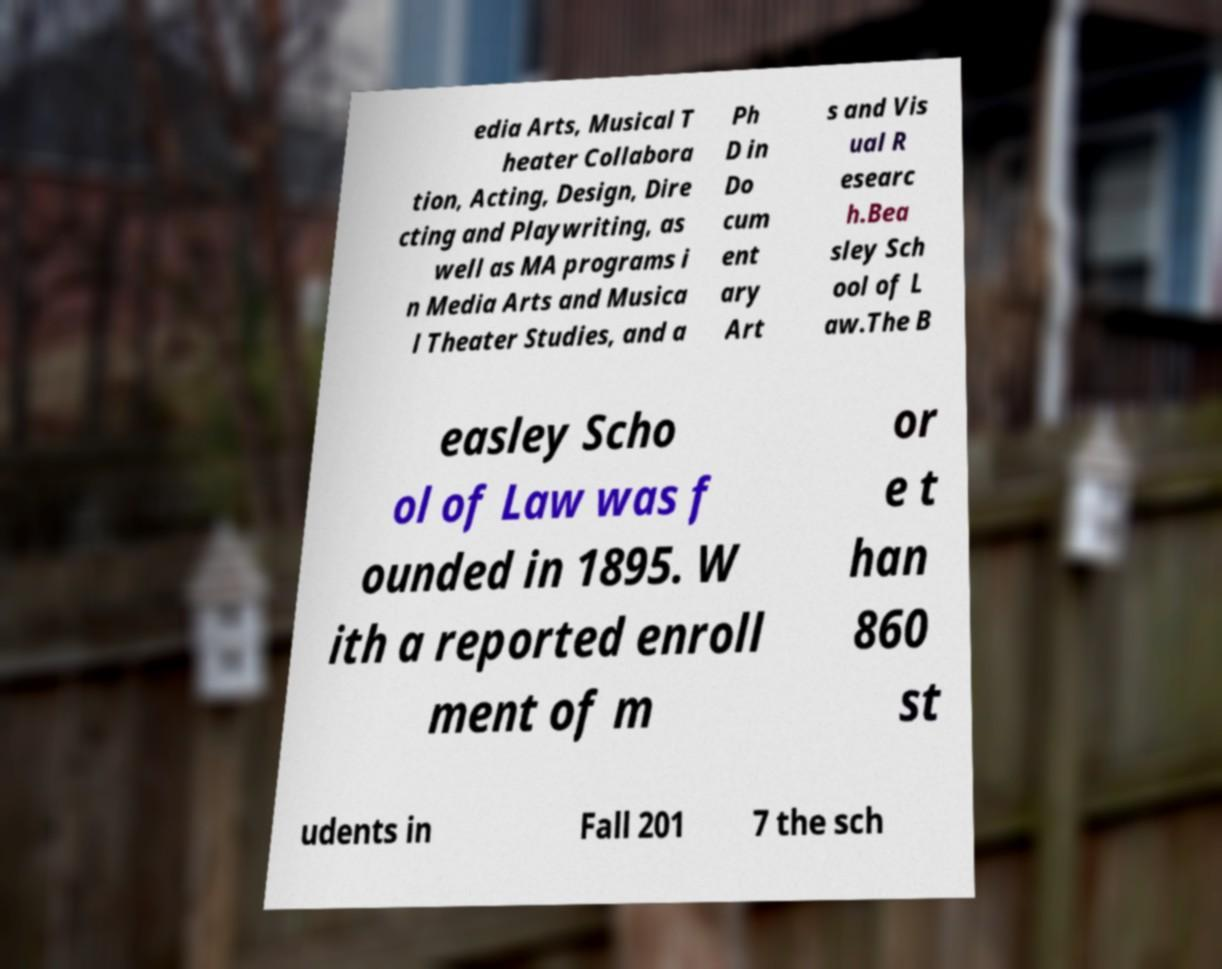Can you read and provide the text displayed in the image?This photo seems to have some interesting text. Can you extract and type it out for me? edia Arts, Musical T heater Collabora tion, Acting, Design, Dire cting and Playwriting, as well as MA programs i n Media Arts and Musica l Theater Studies, and a Ph D in Do cum ent ary Art s and Vis ual R esearc h.Bea sley Sch ool of L aw.The B easley Scho ol of Law was f ounded in 1895. W ith a reported enroll ment of m or e t han 860 st udents in Fall 201 7 the sch 